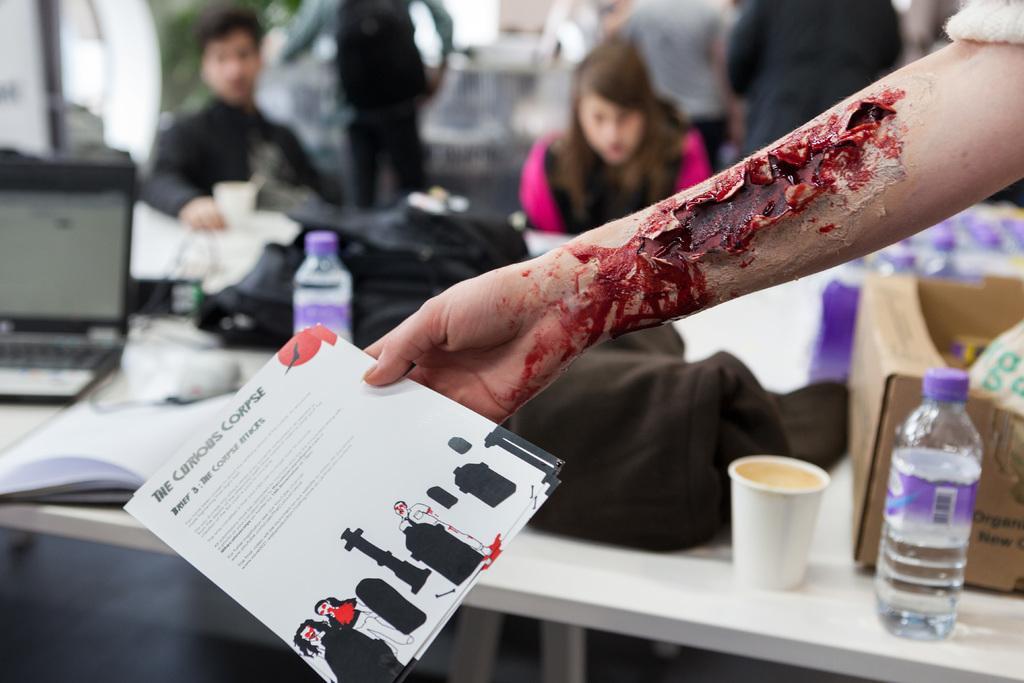Describe this image in one or two sentences. In this image I can see a hand of a person and its holding a paper. On this table I can see few bottles and a cup, I can also see a laptop and few more people. 